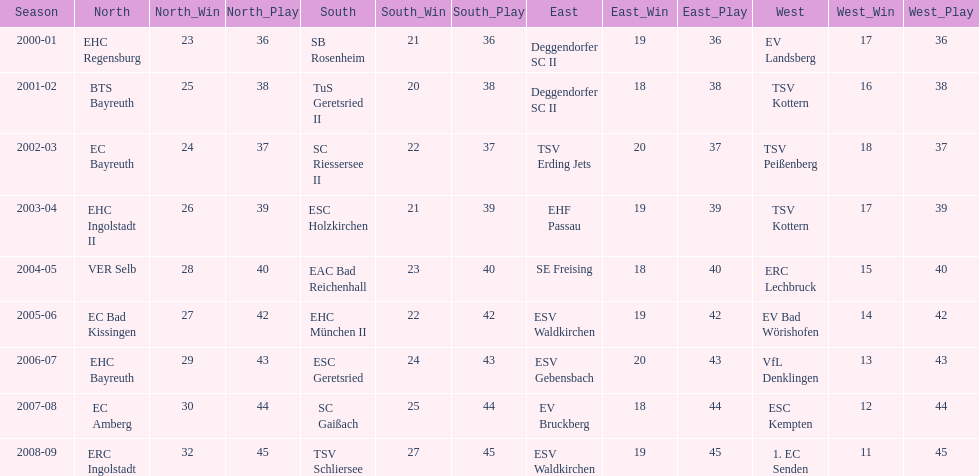What is the number of times deggendorfer sc ii is on the list? 2. Could you help me parse every detail presented in this table? {'header': ['Season', 'North', 'North_Win', 'North_Play', 'South', 'South_Win', 'South_Play', 'East', 'East_Win', 'East_Play', 'West', 'West_Win', 'West_Play'], 'rows': [['2000-01', 'EHC Regensburg', '23', '36', 'SB Rosenheim', '21', '36', 'Deggendorfer SC II', '19', '36', 'EV Landsberg', '17', '36'], ['2001-02', 'BTS Bayreuth', '25', '38', 'TuS Geretsried II', '20', '38', 'Deggendorfer SC II', '18', '38', 'TSV Kottern', '16', '38'], ['2002-03', 'EC Bayreuth', '24', '37', 'SC Riessersee II', '22', '37', 'TSV Erding Jets', '20', '37', 'TSV Peißenberg', '18', '37'], ['2003-04', 'EHC Ingolstadt II', '26', '39', 'ESC Holzkirchen', '21', '39', 'EHF Passau', '19', '39', 'TSV Kottern', '17', '39'], ['2004-05', 'VER Selb', '28', '40', 'EAC Bad Reichenhall', '23', '40', 'SE Freising', '18', '40', 'ERC Lechbruck', '15', '40'], ['2005-06', 'EC Bad Kissingen', '27', '42', 'EHC München II', '22', '42', 'ESV Waldkirchen', '19', '42', 'EV Bad Wörishofen', '14', '42'], ['2006-07', 'EHC Bayreuth', '29', '43', 'ESC Geretsried', '24', '43', 'ESV Gebensbach', '20', '43', 'VfL Denklingen', '13', '43'], ['2007-08', 'EC Amberg', '30', '44', 'SC Gaißach', '25', '44', 'EV Bruckberg', '18', '44', 'ESC Kempten', '12', '44'], ['2008-09', 'ERC Ingolstadt', '32', '45', 'TSV Schliersee', '27', '45', 'ESV Waldkirchen', '19', '45', '1. EC Senden', '11', '45']]} 